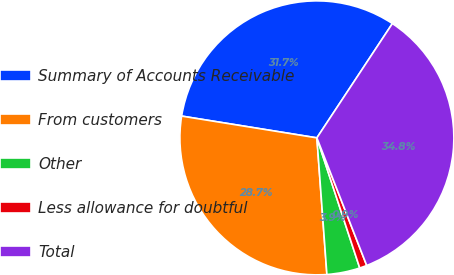Convert chart to OTSL. <chart><loc_0><loc_0><loc_500><loc_500><pie_chart><fcel>Summary of Accounts Receivable<fcel>From customers<fcel>Other<fcel>Less allowance for doubtful<fcel>Total<nl><fcel>31.75%<fcel>28.71%<fcel>3.9%<fcel>0.86%<fcel>34.79%<nl></chart> 